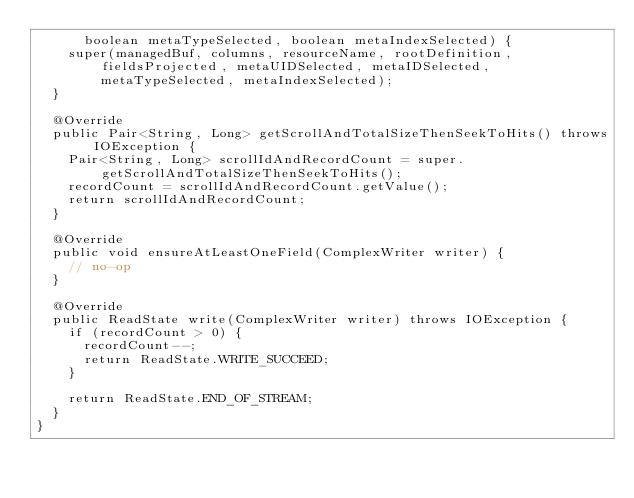Convert code to text. <code><loc_0><loc_0><loc_500><loc_500><_Java_>      boolean metaTypeSelected, boolean metaIndexSelected) {
    super(managedBuf, columns, resourceName, rootDefinition, fieldsProjected, metaUIDSelected, metaIDSelected,
        metaTypeSelected, metaIndexSelected);
  }

  @Override
  public Pair<String, Long> getScrollAndTotalSizeThenSeekToHits() throws IOException {
    Pair<String, Long> scrollIdAndRecordCount = super.getScrollAndTotalSizeThenSeekToHits();
    recordCount = scrollIdAndRecordCount.getValue();
    return scrollIdAndRecordCount;
  }

  @Override
  public void ensureAtLeastOneField(ComplexWriter writer) {
    // no-op
  }

  @Override
  public ReadState write(ComplexWriter writer) throws IOException {
    if (recordCount > 0) {
      recordCount--;
      return ReadState.WRITE_SUCCEED;
    }

    return ReadState.END_OF_STREAM;
  }
}
</code> 